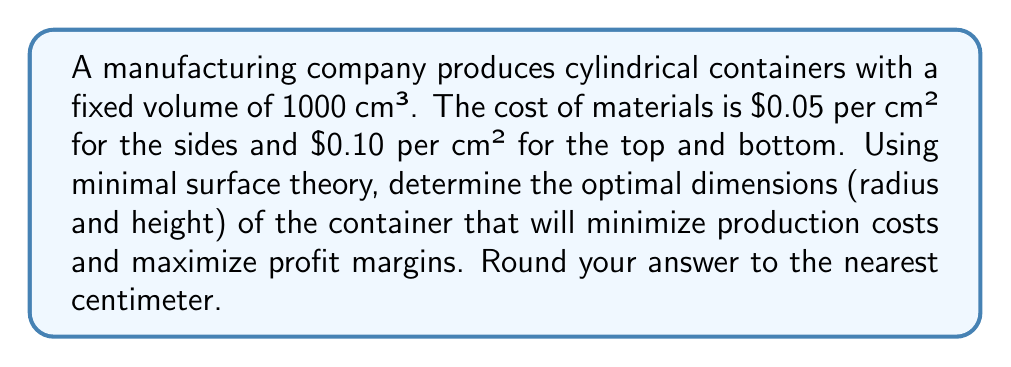Teach me how to tackle this problem. To solve this problem, we'll use the principle of minimal surface area to minimize costs:

1. Let $r$ be the radius and $h$ be the height of the cylinder.

2. The volume of the cylinder is fixed at 1000 cm³:
   $$V = \pi r^2 h = 1000$$

3. The surface area of the cylinder consists of the sides, top, and bottom:
   $$A = 2\pi r h + 2\pi r^2$$

4. Express $h$ in terms of $r$ using the volume equation:
   $$h = \frac{1000}{\pi r^2}$$

5. Substitute this into the surface area equation:
   $$A = 2\pi r (\frac{1000}{\pi r^2}) + 2\pi r^2 = \frac{2000}{r} + 2\pi r^2$$

6. To minimize the surface area (and thus the cost), find the derivative of A with respect to r and set it to zero:
   $$\frac{dA}{dr} = -\frac{2000}{r^2} + 4\pi r = 0$$

7. Solve this equation:
   $$\frac{2000}{r^2} = 4\pi r$$
   $$2000 = 4\pi r^3$$
   $$r^3 = \frac{500}{\pi}$$
   $$r = \sqrt[3]{\frac{500}{\pi}} \approx 5.42 \text{ cm}$$

8. Calculate $h$ using the volume equation:
   $$h = \frac{1000}{\pi r^2} \approx 10.84 \text{ cm}$$

9. Rounding to the nearest centimeter:
   $r = 5 \text{ cm}$, $h = 11 \text{ cm}$

These dimensions will minimize the surface area and thus the production costs, maximizing profit margins.
Answer: $r = 5 \text{ cm}$, $h = 11 \text{ cm}$ 